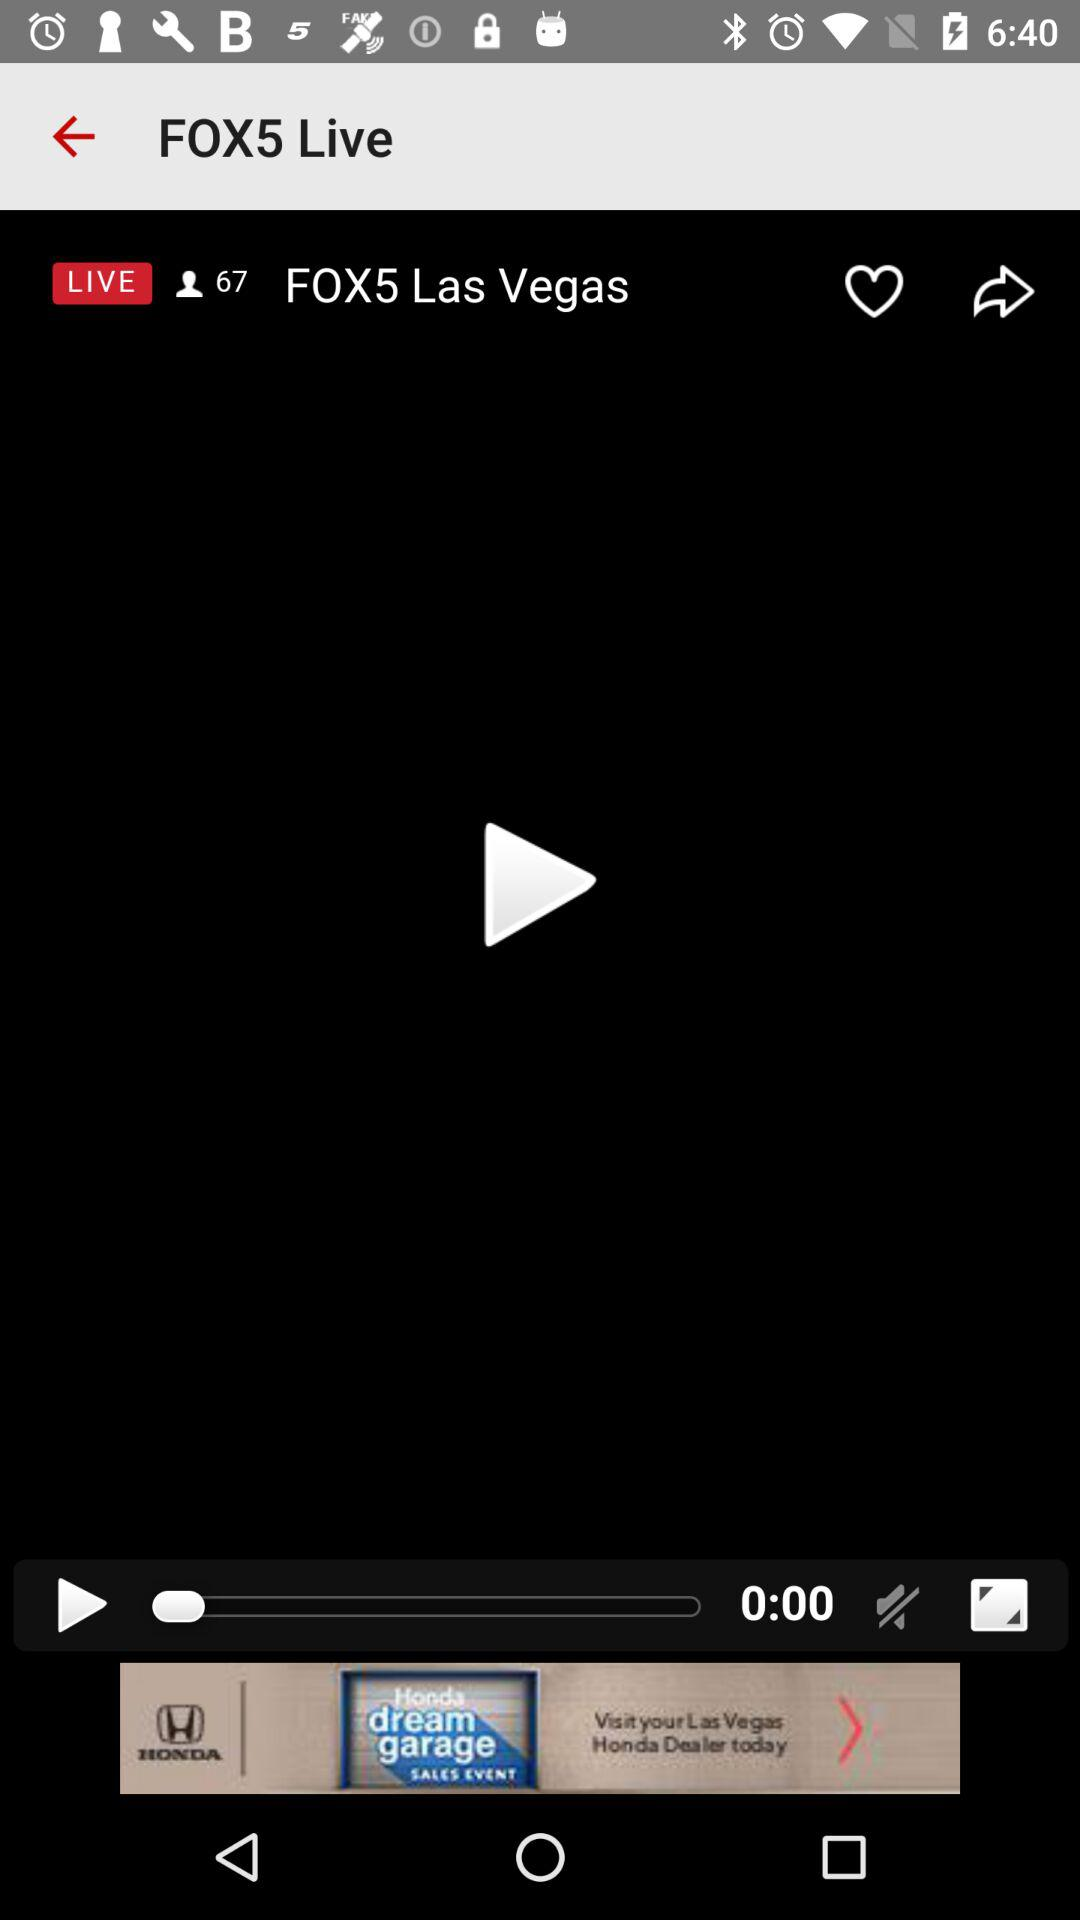What is the time duration? The time duration is 0:00. 